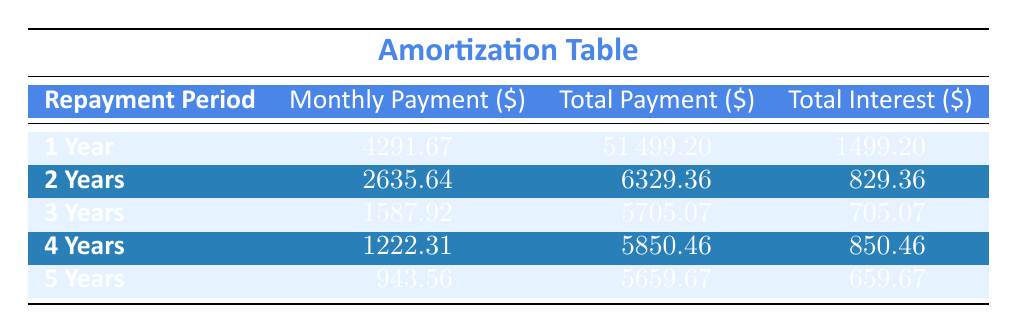What is the monthly payment for a 3-Year loan? The table shows that the monthly payment for the 3-Year loan is listed explicitly in the corresponding row.
Answer: 1587.92 What is the total payment for the 2-Year loan? The table indicates the total payment amount for the 2-Year loan directly in the relevant row.
Answer: 6329.36 Is the interest rate on the loan mentioned in the table? The table does not include the interest rate; it only includes payment details related to the loan.
Answer: No Which repayment period has the highest monthly payment? By comparing the monthly payment amounts listed for each repayment period, the 1-Year loan has the highest monthly payment at 4291.67.
Answer: 1 Year Calculate the total interest paid for all periods combined. Adding the total interest amounts from the table gives: 1499.20 + 829.36 + 705.07 + 850.46 + 659.67 = 3733.76. Hence, the total interest paid is this sum.
Answer: 3733.76 Is the total payment for the 5-Year loan less than that for the 1-Year loan? The total payment for the 5-Year loan is 5659.67, which is less than the total payment for the 1-Year loan, which is 51499.20. This means the statement is true.
Answer: Yes What is the average total payment across all repayment periods? To find the average, we first sum the total payments: 51499.20 + 6329.36 + 5705.07 + 5850.46 + 5659.67 = 70073.76. Then, we divide by the number of periods (5): 70073.76 / 5 = 14014.752.
Answer: 14014.75 What is the difference between the total payment of the 4-Year and 5-Year loans? The total payment for the 4-Year loan is 5850.46, and for the 5-Year loan, it is 5659.67. The difference is found by subtracting these two values: 5850.46 - 5659.67 = 190.79.
Answer: 190.79 What is the total interest for the shortest loan repayment period? The total interest amount for the 1-Year loan is specifically listed in the corresponding row as 1499.20.
Answer: 1499.20 